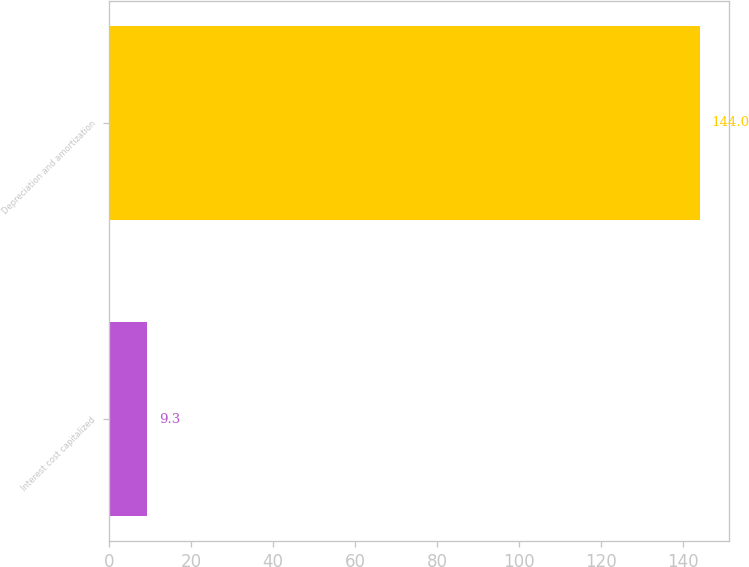Convert chart. <chart><loc_0><loc_0><loc_500><loc_500><bar_chart><fcel>Interest cost capitalized<fcel>Depreciation and amortization<nl><fcel>9.3<fcel>144<nl></chart> 